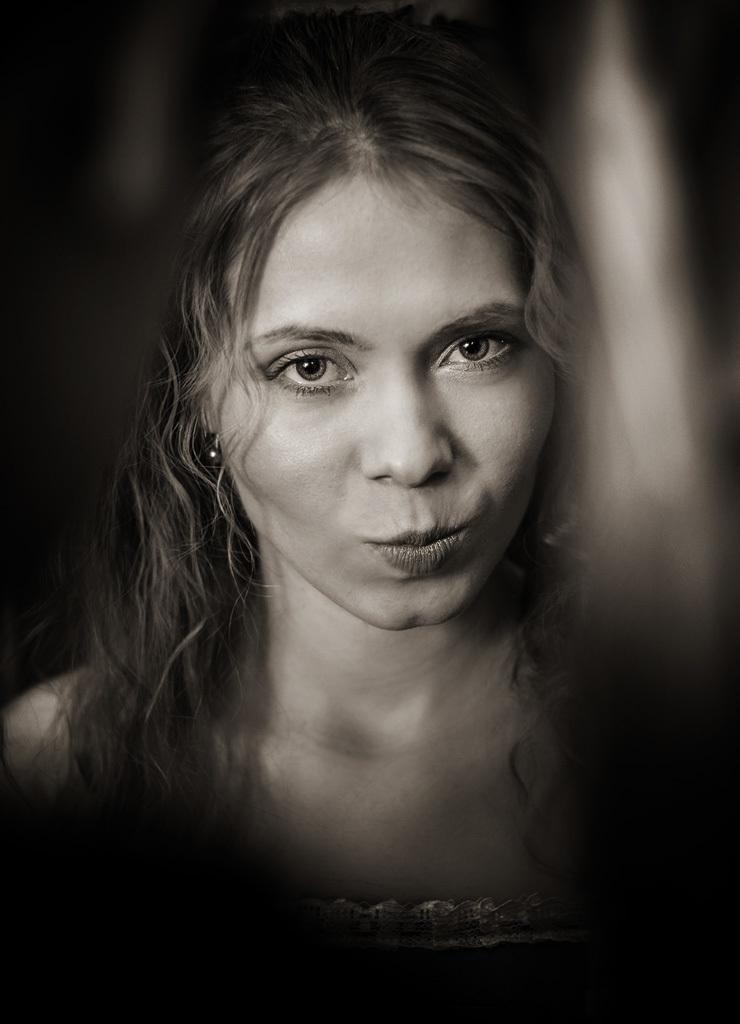What is the main subject of the picture? The main subject of the picture is a woman's face. What color scheme is used in the picture? The picture is black and white. What is the tendency of the cats to play in the background of the image? There are no cats present in the image, so it is not possible to determine any tendencies related to them. 